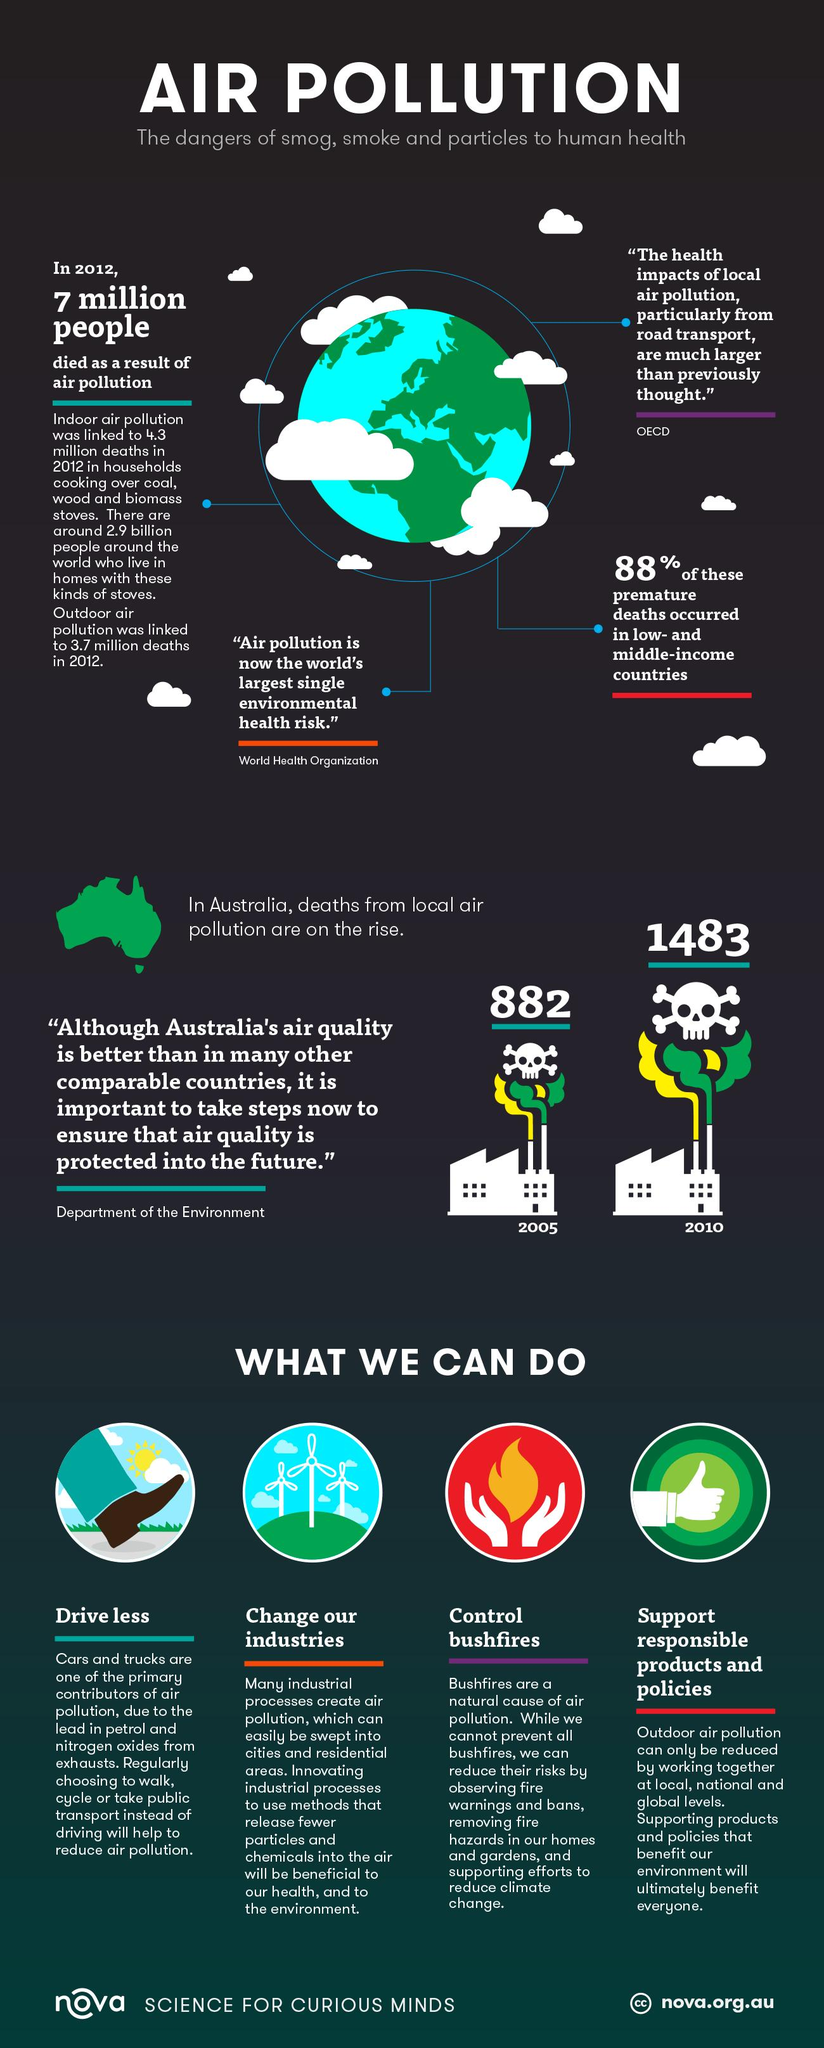Point out several critical features in this image. In 2005, 882 people died as a result of air pollution in Australia. 